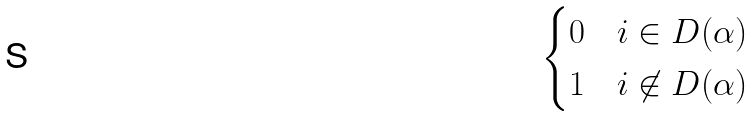Convert formula to latex. <formula><loc_0><loc_0><loc_500><loc_500>\begin{cases} 0 & i \in D ( \alpha ) \\ 1 & i \not \in D ( \alpha ) \end{cases}</formula> 